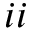<formula> <loc_0><loc_0><loc_500><loc_500>i i</formula> 